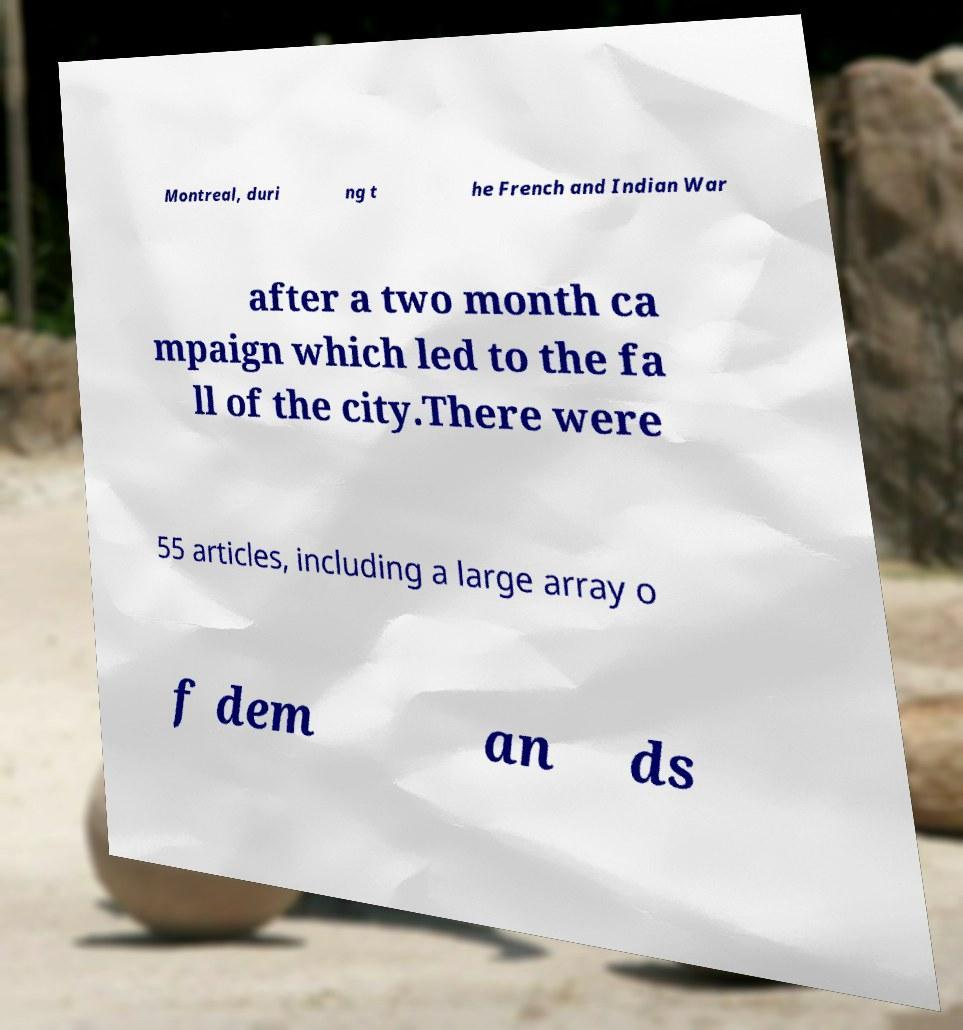Could you assist in decoding the text presented in this image and type it out clearly? Montreal, duri ng t he French and Indian War after a two month ca mpaign which led to the fa ll of the city.There were 55 articles, including a large array o f dem an ds 